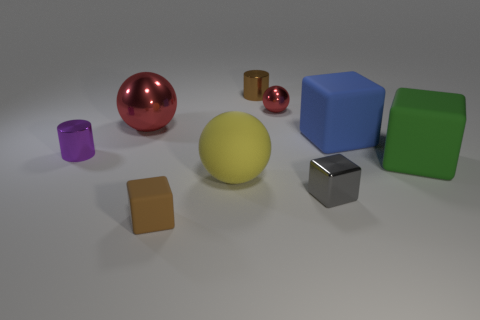Subtract all big spheres. How many spheres are left? 1 Add 1 large gray cylinders. How many objects exist? 10 Subtract all brown blocks. How many red balls are left? 2 Subtract all red balls. How many balls are left? 1 Subtract 2 cylinders. How many cylinders are left? 0 Subtract all cylinders. How many objects are left? 7 Subtract all purple cylinders. Subtract all red spheres. How many cylinders are left? 1 Subtract all blue metallic blocks. Subtract all gray shiny objects. How many objects are left? 8 Add 8 blue cubes. How many blue cubes are left? 9 Add 4 small brown cylinders. How many small brown cylinders exist? 5 